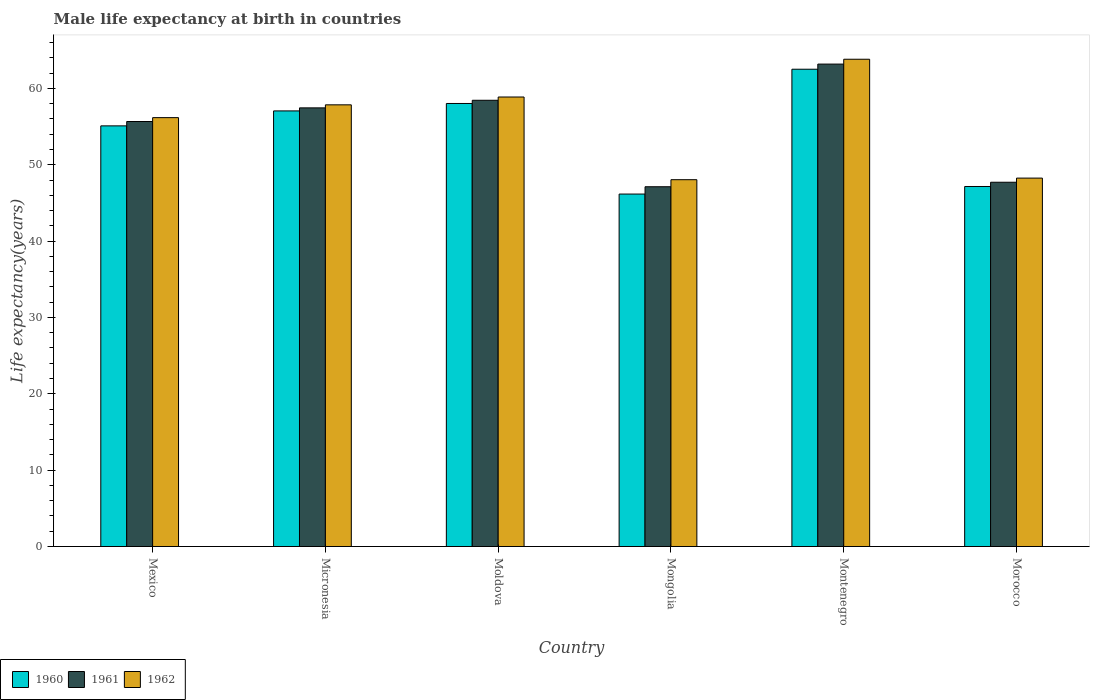How many groups of bars are there?
Give a very brief answer. 6. Are the number of bars per tick equal to the number of legend labels?
Your answer should be compact. Yes. Are the number of bars on each tick of the X-axis equal?
Ensure brevity in your answer.  Yes. What is the label of the 2nd group of bars from the left?
Provide a short and direct response. Micronesia. What is the male life expectancy at birth in 1962 in Mongolia?
Ensure brevity in your answer.  48.04. Across all countries, what is the maximum male life expectancy at birth in 1962?
Provide a succinct answer. 63.82. Across all countries, what is the minimum male life expectancy at birth in 1961?
Ensure brevity in your answer.  47.12. In which country was the male life expectancy at birth in 1962 maximum?
Your response must be concise. Montenegro. In which country was the male life expectancy at birth in 1960 minimum?
Provide a succinct answer. Mongolia. What is the total male life expectancy at birth in 1960 in the graph?
Offer a terse response. 325.99. What is the difference between the male life expectancy at birth in 1962 in Micronesia and that in Morocco?
Offer a terse response. 9.6. What is the difference between the male life expectancy at birth in 1960 in Mexico and the male life expectancy at birth in 1961 in Micronesia?
Provide a short and direct response. -2.36. What is the average male life expectancy at birth in 1961 per country?
Offer a terse response. 54.93. What is the difference between the male life expectancy at birth of/in 1962 and male life expectancy at birth of/in 1960 in Morocco?
Provide a short and direct response. 1.1. What is the ratio of the male life expectancy at birth in 1960 in Micronesia to that in Montenegro?
Provide a succinct answer. 0.91. What is the difference between the highest and the second highest male life expectancy at birth in 1962?
Your response must be concise. -1.02. What is the difference between the highest and the lowest male life expectancy at birth in 1960?
Offer a terse response. 16.35. In how many countries, is the male life expectancy at birth in 1962 greater than the average male life expectancy at birth in 1962 taken over all countries?
Ensure brevity in your answer.  4. What does the 3rd bar from the left in Montenegro represents?
Make the answer very short. 1962. Is it the case that in every country, the sum of the male life expectancy at birth in 1961 and male life expectancy at birth in 1962 is greater than the male life expectancy at birth in 1960?
Offer a very short reply. Yes. How many bars are there?
Your answer should be very brief. 18. Are the values on the major ticks of Y-axis written in scientific E-notation?
Offer a very short reply. No. Does the graph contain any zero values?
Your answer should be compact. No. Does the graph contain grids?
Your answer should be very brief. No. What is the title of the graph?
Your answer should be very brief. Male life expectancy at birth in countries. Does "1995" appear as one of the legend labels in the graph?
Keep it short and to the point. No. What is the label or title of the Y-axis?
Offer a terse response. Life expectancy(years). What is the Life expectancy(years) in 1960 in Mexico?
Offer a very short reply. 55.09. What is the Life expectancy(years) of 1961 in Mexico?
Offer a very short reply. 55.66. What is the Life expectancy(years) in 1962 in Mexico?
Provide a short and direct response. 56.17. What is the Life expectancy(years) of 1960 in Micronesia?
Give a very brief answer. 57.05. What is the Life expectancy(years) of 1961 in Micronesia?
Ensure brevity in your answer.  57.45. What is the Life expectancy(years) in 1962 in Micronesia?
Keep it short and to the point. 57.85. What is the Life expectancy(years) of 1960 in Moldova?
Your answer should be compact. 58.02. What is the Life expectancy(years) of 1961 in Moldova?
Make the answer very short. 58.44. What is the Life expectancy(years) of 1962 in Moldova?
Offer a very short reply. 58.87. What is the Life expectancy(years) in 1960 in Mongolia?
Your response must be concise. 46.16. What is the Life expectancy(years) of 1961 in Mongolia?
Your answer should be very brief. 47.12. What is the Life expectancy(years) in 1962 in Mongolia?
Keep it short and to the point. 48.04. What is the Life expectancy(years) in 1960 in Montenegro?
Provide a short and direct response. 62.51. What is the Life expectancy(years) of 1961 in Montenegro?
Provide a succinct answer. 63.18. What is the Life expectancy(years) in 1962 in Montenegro?
Give a very brief answer. 63.82. What is the Life expectancy(years) in 1960 in Morocco?
Keep it short and to the point. 47.15. What is the Life expectancy(years) in 1961 in Morocco?
Ensure brevity in your answer.  47.71. What is the Life expectancy(years) in 1962 in Morocco?
Offer a very short reply. 48.25. Across all countries, what is the maximum Life expectancy(years) of 1960?
Offer a terse response. 62.51. Across all countries, what is the maximum Life expectancy(years) of 1961?
Provide a succinct answer. 63.18. Across all countries, what is the maximum Life expectancy(years) in 1962?
Your answer should be compact. 63.82. Across all countries, what is the minimum Life expectancy(years) of 1960?
Your answer should be very brief. 46.16. Across all countries, what is the minimum Life expectancy(years) in 1961?
Your answer should be compact. 47.12. Across all countries, what is the minimum Life expectancy(years) of 1962?
Provide a short and direct response. 48.04. What is the total Life expectancy(years) of 1960 in the graph?
Ensure brevity in your answer.  325.99. What is the total Life expectancy(years) of 1961 in the graph?
Provide a succinct answer. 329.56. What is the total Life expectancy(years) of 1962 in the graph?
Offer a terse response. 333. What is the difference between the Life expectancy(years) in 1960 in Mexico and that in Micronesia?
Offer a terse response. -1.96. What is the difference between the Life expectancy(years) of 1961 in Mexico and that in Micronesia?
Your answer should be compact. -1.79. What is the difference between the Life expectancy(years) of 1962 in Mexico and that in Micronesia?
Offer a terse response. -1.68. What is the difference between the Life expectancy(years) of 1960 in Mexico and that in Moldova?
Offer a very short reply. -2.93. What is the difference between the Life expectancy(years) in 1961 in Mexico and that in Moldova?
Give a very brief answer. -2.78. What is the difference between the Life expectancy(years) of 1962 in Mexico and that in Moldova?
Your answer should be compact. -2.7. What is the difference between the Life expectancy(years) in 1960 in Mexico and that in Mongolia?
Make the answer very short. 8.93. What is the difference between the Life expectancy(years) of 1961 in Mexico and that in Mongolia?
Make the answer very short. 8.54. What is the difference between the Life expectancy(years) in 1962 in Mexico and that in Mongolia?
Give a very brief answer. 8.13. What is the difference between the Life expectancy(years) of 1960 in Mexico and that in Montenegro?
Provide a short and direct response. -7.42. What is the difference between the Life expectancy(years) in 1961 in Mexico and that in Montenegro?
Give a very brief answer. -7.52. What is the difference between the Life expectancy(years) of 1962 in Mexico and that in Montenegro?
Ensure brevity in your answer.  -7.65. What is the difference between the Life expectancy(years) of 1960 in Mexico and that in Morocco?
Offer a terse response. 7.94. What is the difference between the Life expectancy(years) in 1961 in Mexico and that in Morocco?
Ensure brevity in your answer.  7.95. What is the difference between the Life expectancy(years) in 1962 in Mexico and that in Morocco?
Make the answer very short. 7.92. What is the difference between the Life expectancy(years) in 1960 in Micronesia and that in Moldova?
Your answer should be very brief. -0.97. What is the difference between the Life expectancy(years) in 1961 in Micronesia and that in Moldova?
Ensure brevity in your answer.  -0.99. What is the difference between the Life expectancy(years) in 1962 in Micronesia and that in Moldova?
Your answer should be very brief. -1.02. What is the difference between the Life expectancy(years) of 1960 in Micronesia and that in Mongolia?
Provide a short and direct response. 10.89. What is the difference between the Life expectancy(years) in 1961 in Micronesia and that in Mongolia?
Your answer should be very brief. 10.33. What is the difference between the Life expectancy(years) of 1962 in Micronesia and that in Mongolia?
Ensure brevity in your answer.  9.8. What is the difference between the Life expectancy(years) in 1960 in Micronesia and that in Montenegro?
Your answer should be very brief. -5.46. What is the difference between the Life expectancy(years) of 1961 in Micronesia and that in Montenegro?
Offer a terse response. -5.73. What is the difference between the Life expectancy(years) of 1962 in Micronesia and that in Montenegro?
Your answer should be very brief. -5.97. What is the difference between the Life expectancy(years) of 1960 in Micronesia and that in Morocco?
Your answer should be very brief. 9.9. What is the difference between the Life expectancy(years) of 1961 in Micronesia and that in Morocco?
Ensure brevity in your answer.  9.74. What is the difference between the Life expectancy(years) of 1962 in Micronesia and that in Morocco?
Ensure brevity in your answer.  9.6. What is the difference between the Life expectancy(years) of 1960 in Moldova and that in Mongolia?
Offer a very short reply. 11.86. What is the difference between the Life expectancy(years) in 1961 in Moldova and that in Mongolia?
Keep it short and to the point. 11.33. What is the difference between the Life expectancy(years) in 1962 in Moldova and that in Mongolia?
Your answer should be compact. 10.83. What is the difference between the Life expectancy(years) in 1960 in Moldova and that in Montenegro?
Offer a very short reply. -4.49. What is the difference between the Life expectancy(years) in 1961 in Moldova and that in Montenegro?
Your answer should be compact. -4.74. What is the difference between the Life expectancy(years) in 1962 in Moldova and that in Montenegro?
Offer a very short reply. -4.95. What is the difference between the Life expectancy(years) of 1960 in Moldova and that in Morocco?
Give a very brief answer. 10.87. What is the difference between the Life expectancy(years) of 1961 in Moldova and that in Morocco?
Give a very brief answer. 10.73. What is the difference between the Life expectancy(years) in 1962 in Moldova and that in Morocco?
Make the answer very short. 10.62. What is the difference between the Life expectancy(years) in 1960 in Mongolia and that in Montenegro?
Make the answer very short. -16.35. What is the difference between the Life expectancy(years) in 1961 in Mongolia and that in Montenegro?
Your response must be concise. -16.07. What is the difference between the Life expectancy(years) in 1962 in Mongolia and that in Montenegro?
Provide a succinct answer. -15.78. What is the difference between the Life expectancy(years) of 1960 in Mongolia and that in Morocco?
Make the answer very short. -0.99. What is the difference between the Life expectancy(years) in 1961 in Mongolia and that in Morocco?
Offer a very short reply. -0.59. What is the difference between the Life expectancy(years) of 1962 in Mongolia and that in Morocco?
Provide a short and direct response. -0.21. What is the difference between the Life expectancy(years) in 1960 in Montenegro and that in Morocco?
Give a very brief answer. 15.36. What is the difference between the Life expectancy(years) of 1961 in Montenegro and that in Morocco?
Keep it short and to the point. 15.47. What is the difference between the Life expectancy(years) of 1962 in Montenegro and that in Morocco?
Your answer should be compact. 15.57. What is the difference between the Life expectancy(years) in 1960 in Mexico and the Life expectancy(years) in 1961 in Micronesia?
Keep it short and to the point. -2.36. What is the difference between the Life expectancy(years) in 1960 in Mexico and the Life expectancy(years) in 1962 in Micronesia?
Keep it short and to the point. -2.76. What is the difference between the Life expectancy(years) in 1961 in Mexico and the Life expectancy(years) in 1962 in Micronesia?
Your answer should be very brief. -2.19. What is the difference between the Life expectancy(years) of 1960 in Mexico and the Life expectancy(years) of 1961 in Moldova?
Your response must be concise. -3.35. What is the difference between the Life expectancy(years) of 1960 in Mexico and the Life expectancy(years) of 1962 in Moldova?
Give a very brief answer. -3.78. What is the difference between the Life expectancy(years) in 1961 in Mexico and the Life expectancy(years) in 1962 in Moldova?
Provide a succinct answer. -3.21. What is the difference between the Life expectancy(years) in 1960 in Mexico and the Life expectancy(years) in 1961 in Mongolia?
Offer a terse response. 7.97. What is the difference between the Life expectancy(years) of 1960 in Mexico and the Life expectancy(years) of 1962 in Mongolia?
Provide a succinct answer. 7.05. What is the difference between the Life expectancy(years) in 1961 in Mexico and the Life expectancy(years) in 1962 in Mongolia?
Offer a terse response. 7.62. What is the difference between the Life expectancy(years) of 1960 in Mexico and the Life expectancy(years) of 1961 in Montenegro?
Keep it short and to the point. -8.09. What is the difference between the Life expectancy(years) of 1960 in Mexico and the Life expectancy(years) of 1962 in Montenegro?
Ensure brevity in your answer.  -8.73. What is the difference between the Life expectancy(years) of 1961 in Mexico and the Life expectancy(years) of 1962 in Montenegro?
Ensure brevity in your answer.  -8.16. What is the difference between the Life expectancy(years) of 1960 in Mexico and the Life expectancy(years) of 1961 in Morocco?
Offer a very short reply. 7.38. What is the difference between the Life expectancy(years) in 1960 in Mexico and the Life expectancy(years) in 1962 in Morocco?
Give a very brief answer. 6.84. What is the difference between the Life expectancy(years) of 1961 in Mexico and the Life expectancy(years) of 1962 in Morocco?
Provide a succinct answer. 7.41. What is the difference between the Life expectancy(years) in 1960 in Micronesia and the Life expectancy(years) in 1961 in Moldova?
Keep it short and to the point. -1.39. What is the difference between the Life expectancy(years) in 1960 in Micronesia and the Life expectancy(years) in 1962 in Moldova?
Give a very brief answer. -1.82. What is the difference between the Life expectancy(years) of 1961 in Micronesia and the Life expectancy(years) of 1962 in Moldova?
Offer a very short reply. -1.42. What is the difference between the Life expectancy(years) of 1960 in Micronesia and the Life expectancy(years) of 1961 in Mongolia?
Ensure brevity in your answer.  9.93. What is the difference between the Life expectancy(years) in 1960 in Micronesia and the Life expectancy(years) in 1962 in Mongolia?
Your answer should be very brief. 9.01. What is the difference between the Life expectancy(years) of 1961 in Micronesia and the Life expectancy(years) of 1962 in Mongolia?
Make the answer very short. 9.41. What is the difference between the Life expectancy(years) of 1960 in Micronesia and the Life expectancy(years) of 1961 in Montenegro?
Your answer should be compact. -6.13. What is the difference between the Life expectancy(years) in 1960 in Micronesia and the Life expectancy(years) in 1962 in Montenegro?
Offer a terse response. -6.77. What is the difference between the Life expectancy(years) of 1961 in Micronesia and the Life expectancy(years) of 1962 in Montenegro?
Your answer should be very brief. -6.37. What is the difference between the Life expectancy(years) in 1960 in Micronesia and the Life expectancy(years) in 1961 in Morocco?
Keep it short and to the point. 9.34. What is the difference between the Life expectancy(years) in 1960 in Micronesia and the Life expectancy(years) in 1962 in Morocco?
Provide a short and direct response. 8.8. What is the difference between the Life expectancy(years) in 1961 in Micronesia and the Life expectancy(years) in 1962 in Morocco?
Offer a very short reply. 9.2. What is the difference between the Life expectancy(years) in 1960 in Moldova and the Life expectancy(years) in 1961 in Mongolia?
Your answer should be compact. 10.91. What is the difference between the Life expectancy(years) in 1960 in Moldova and the Life expectancy(years) in 1962 in Mongolia?
Ensure brevity in your answer.  9.98. What is the difference between the Life expectancy(years) in 1961 in Moldova and the Life expectancy(years) in 1962 in Mongolia?
Offer a very short reply. 10.4. What is the difference between the Life expectancy(years) in 1960 in Moldova and the Life expectancy(years) in 1961 in Montenegro?
Your answer should be compact. -5.16. What is the difference between the Life expectancy(years) in 1960 in Moldova and the Life expectancy(years) in 1962 in Montenegro?
Provide a short and direct response. -5.79. What is the difference between the Life expectancy(years) of 1961 in Moldova and the Life expectancy(years) of 1962 in Montenegro?
Your response must be concise. -5.37. What is the difference between the Life expectancy(years) in 1960 in Moldova and the Life expectancy(years) in 1961 in Morocco?
Your answer should be compact. 10.31. What is the difference between the Life expectancy(years) of 1960 in Moldova and the Life expectancy(years) of 1962 in Morocco?
Make the answer very short. 9.77. What is the difference between the Life expectancy(years) of 1961 in Moldova and the Life expectancy(years) of 1962 in Morocco?
Make the answer very short. 10.19. What is the difference between the Life expectancy(years) of 1960 in Mongolia and the Life expectancy(years) of 1961 in Montenegro?
Provide a short and direct response. -17.02. What is the difference between the Life expectancy(years) of 1960 in Mongolia and the Life expectancy(years) of 1962 in Montenegro?
Offer a very short reply. -17.66. What is the difference between the Life expectancy(years) in 1961 in Mongolia and the Life expectancy(years) in 1962 in Montenegro?
Your answer should be compact. -16.7. What is the difference between the Life expectancy(years) in 1960 in Mongolia and the Life expectancy(years) in 1961 in Morocco?
Offer a very short reply. -1.55. What is the difference between the Life expectancy(years) in 1960 in Mongolia and the Life expectancy(years) in 1962 in Morocco?
Keep it short and to the point. -2.09. What is the difference between the Life expectancy(years) in 1961 in Mongolia and the Life expectancy(years) in 1962 in Morocco?
Provide a succinct answer. -1.13. What is the difference between the Life expectancy(years) in 1960 in Montenegro and the Life expectancy(years) in 1961 in Morocco?
Your answer should be very brief. 14.8. What is the difference between the Life expectancy(years) in 1960 in Montenegro and the Life expectancy(years) in 1962 in Morocco?
Provide a short and direct response. 14.26. What is the difference between the Life expectancy(years) in 1961 in Montenegro and the Life expectancy(years) in 1962 in Morocco?
Provide a succinct answer. 14.93. What is the average Life expectancy(years) in 1960 per country?
Keep it short and to the point. 54.33. What is the average Life expectancy(years) of 1961 per country?
Ensure brevity in your answer.  54.93. What is the average Life expectancy(years) of 1962 per country?
Ensure brevity in your answer.  55.5. What is the difference between the Life expectancy(years) of 1960 and Life expectancy(years) of 1961 in Mexico?
Keep it short and to the point. -0.57. What is the difference between the Life expectancy(years) in 1960 and Life expectancy(years) in 1962 in Mexico?
Ensure brevity in your answer.  -1.08. What is the difference between the Life expectancy(years) in 1961 and Life expectancy(years) in 1962 in Mexico?
Offer a very short reply. -0.51. What is the difference between the Life expectancy(years) in 1960 and Life expectancy(years) in 1961 in Micronesia?
Offer a terse response. -0.4. What is the difference between the Life expectancy(years) of 1960 and Life expectancy(years) of 1962 in Micronesia?
Your response must be concise. -0.8. What is the difference between the Life expectancy(years) of 1961 and Life expectancy(years) of 1962 in Micronesia?
Your answer should be very brief. -0.4. What is the difference between the Life expectancy(years) in 1960 and Life expectancy(years) in 1961 in Moldova?
Make the answer very short. -0.42. What is the difference between the Life expectancy(years) in 1960 and Life expectancy(years) in 1962 in Moldova?
Your answer should be very brief. -0.85. What is the difference between the Life expectancy(years) in 1961 and Life expectancy(years) in 1962 in Moldova?
Keep it short and to the point. -0.43. What is the difference between the Life expectancy(years) of 1960 and Life expectancy(years) of 1961 in Mongolia?
Your answer should be very brief. -0.96. What is the difference between the Life expectancy(years) of 1960 and Life expectancy(years) of 1962 in Mongolia?
Your answer should be compact. -1.88. What is the difference between the Life expectancy(years) of 1961 and Life expectancy(years) of 1962 in Mongolia?
Give a very brief answer. -0.92. What is the difference between the Life expectancy(years) of 1960 and Life expectancy(years) of 1961 in Montenegro?
Your answer should be very brief. -0.67. What is the difference between the Life expectancy(years) in 1960 and Life expectancy(years) in 1962 in Montenegro?
Ensure brevity in your answer.  -1.31. What is the difference between the Life expectancy(years) of 1961 and Life expectancy(years) of 1962 in Montenegro?
Your response must be concise. -0.64. What is the difference between the Life expectancy(years) in 1960 and Life expectancy(years) in 1961 in Morocco?
Offer a very short reply. -0.56. What is the difference between the Life expectancy(years) of 1960 and Life expectancy(years) of 1962 in Morocco?
Make the answer very short. -1.1. What is the difference between the Life expectancy(years) of 1961 and Life expectancy(years) of 1962 in Morocco?
Your answer should be compact. -0.54. What is the ratio of the Life expectancy(years) of 1960 in Mexico to that in Micronesia?
Make the answer very short. 0.97. What is the ratio of the Life expectancy(years) in 1961 in Mexico to that in Micronesia?
Your answer should be very brief. 0.97. What is the ratio of the Life expectancy(years) in 1960 in Mexico to that in Moldova?
Your answer should be very brief. 0.95. What is the ratio of the Life expectancy(years) of 1962 in Mexico to that in Moldova?
Give a very brief answer. 0.95. What is the ratio of the Life expectancy(years) in 1960 in Mexico to that in Mongolia?
Provide a short and direct response. 1.19. What is the ratio of the Life expectancy(years) of 1961 in Mexico to that in Mongolia?
Provide a short and direct response. 1.18. What is the ratio of the Life expectancy(years) in 1962 in Mexico to that in Mongolia?
Keep it short and to the point. 1.17. What is the ratio of the Life expectancy(years) in 1960 in Mexico to that in Montenegro?
Provide a short and direct response. 0.88. What is the ratio of the Life expectancy(years) of 1961 in Mexico to that in Montenegro?
Your answer should be compact. 0.88. What is the ratio of the Life expectancy(years) of 1962 in Mexico to that in Montenegro?
Your answer should be compact. 0.88. What is the ratio of the Life expectancy(years) of 1960 in Mexico to that in Morocco?
Provide a succinct answer. 1.17. What is the ratio of the Life expectancy(years) in 1962 in Mexico to that in Morocco?
Offer a very short reply. 1.16. What is the ratio of the Life expectancy(years) in 1960 in Micronesia to that in Moldova?
Make the answer very short. 0.98. What is the ratio of the Life expectancy(years) of 1961 in Micronesia to that in Moldova?
Keep it short and to the point. 0.98. What is the ratio of the Life expectancy(years) in 1962 in Micronesia to that in Moldova?
Ensure brevity in your answer.  0.98. What is the ratio of the Life expectancy(years) in 1960 in Micronesia to that in Mongolia?
Give a very brief answer. 1.24. What is the ratio of the Life expectancy(years) in 1961 in Micronesia to that in Mongolia?
Offer a terse response. 1.22. What is the ratio of the Life expectancy(years) in 1962 in Micronesia to that in Mongolia?
Offer a very short reply. 1.2. What is the ratio of the Life expectancy(years) of 1960 in Micronesia to that in Montenegro?
Your response must be concise. 0.91. What is the ratio of the Life expectancy(years) of 1961 in Micronesia to that in Montenegro?
Offer a terse response. 0.91. What is the ratio of the Life expectancy(years) of 1962 in Micronesia to that in Montenegro?
Provide a short and direct response. 0.91. What is the ratio of the Life expectancy(years) of 1960 in Micronesia to that in Morocco?
Provide a short and direct response. 1.21. What is the ratio of the Life expectancy(years) of 1961 in Micronesia to that in Morocco?
Your answer should be very brief. 1.2. What is the ratio of the Life expectancy(years) of 1962 in Micronesia to that in Morocco?
Give a very brief answer. 1.2. What is the ratio of the Life expectancy(years) of 1960 in Moldova to that in Mongolia?
Ensure brevity in your answer.  1.26. What is the ratio of the Life expectancy(years) in 1961 in Moldova to that in Mongolia?
Provide a short and direct response. 1.24. What is the ratio of the Life expectancy(years) in 1962 in Moldova to that in Mongolia?
Offer a very short reply. 1.23. What is the ratio of the Life expectancy(years) of 1960 in Moldova to that in Montenegro?
Keep it short and to the point. 0.93. What is the ratio of the Life expectancy(years) of 1961 in Moldova to that in Montenegro?
Offer a very short reply. 0.93. What is the ratio of the Life expectancy(years) in 1962 in Moldova to that in Montenegro?
Keep it short and to the point. 0.92. What is the ratio of the Life expectancy(years) in 1960 in Moldova to that in Morocco?
Your answer should be very brief. 1.23. What is the ratio of the Life expectancy(years) in 1961 in Moldova to that in Morocco?
Make the answer very short. 1.23. What is the ratio of the Life expectancy(years) in 1962 in Moldova to that in Morocco?
Your answer should be very brief. 1.22. What is the ratio of the Life expectancy(years) in 1960 in Mongolia to that in Montenegro?
Your answer should be compact. 0.74. What is the ratio of the Life expectancy(years) of 1961 in Mongolia to that in Montenegro?
Your answer should be compact. 0.75. What is the ratio of the Life expectancy(years) of 1962 in Mongolia to that in Montenegro?
Ensure brevity in your answer.  0.75. What is the ratio of the Life expectancy(years) of 1961 in Mongolia to that in Morocco?
Your answer should be very brief. 0.99. What is the ratio of the Life expectancy(years) in 1962 in Mongolia to that in Morocco?
Make the answer very short. 1. What is the ratio of the Life expectancy(years) in 1960 in Montenegro to that in Morocco?
Keep it short and to the point. 1.33. What is the ratio of the Life expectancy(years) in 1961 in Montenegro to that in Morocco?
Provide a short and direct response. 1.32. What is the ratio of the Life expectancy(years) in 1962 in Montenegro to that in Morocco?
Offer a very short reply. 1.32. What is the difference between the highest and the second highest Life expectancy(years) in 1960?
Your answer should be compact. 4.49. What is the difference between the highest and the second highest Life expectancy(years) of 1961?
Offer a terse response. 4.74. What is the difference between the highest and the second highest Life expectancy(years) of 1962?
Keep it short and to the point. 4.95. What is the difference between the highest and the lowest Life expectancy(years) of 1960?
Your response must be concise. 16.35. What is the difference between the highest and the lowest Life expectancy(years) in 1961?
Your response must be concise. 16.07. What is the difference between the highest and the lowest Life expectancy(years) of 1962?
Provide a short and direct response. 15.78. 